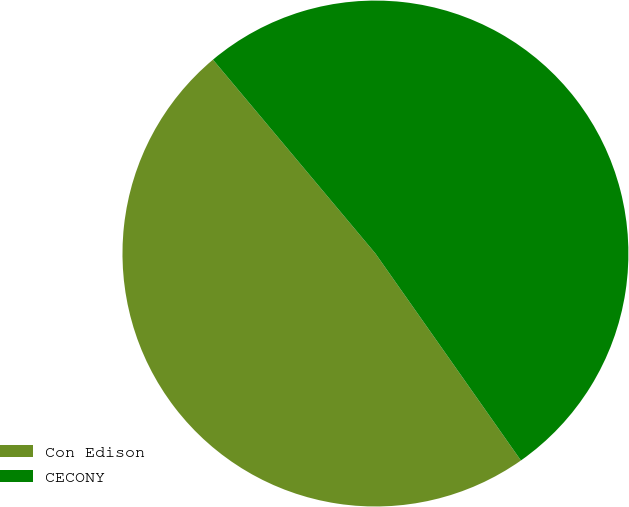Convert chart to OTSL. <chart><loc_0><loc_0><loc_500><loc_500><pie_chart><fcel>Con Edison<fcel>CECONY<nl><fcel>48.65%<fcel>51.35%<nl></chart> 